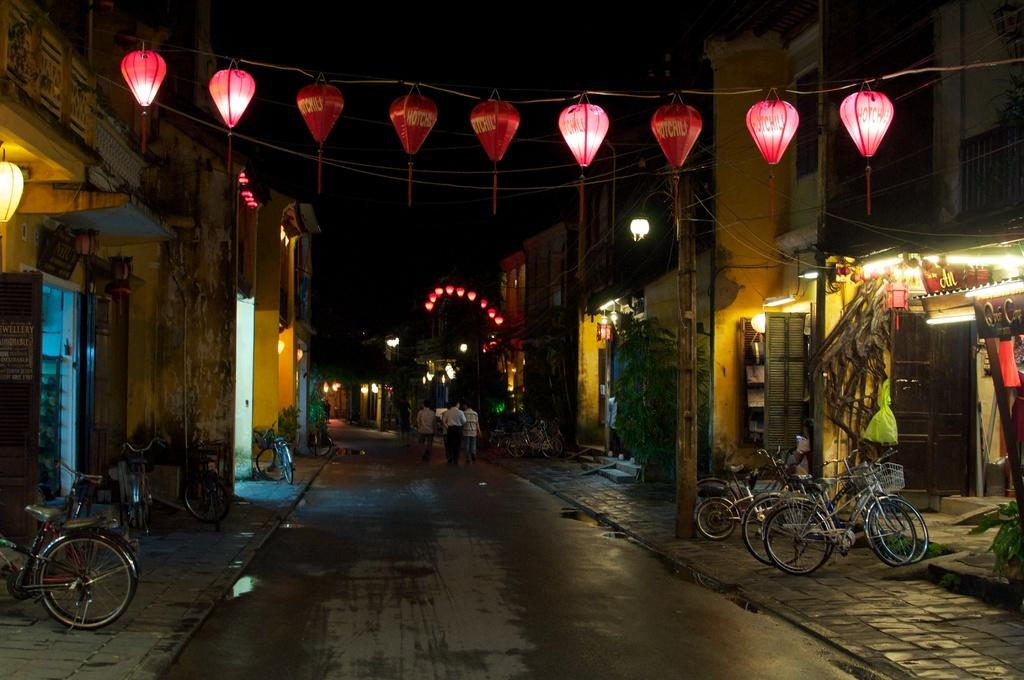What can be seen parked on the sidewalk in the image? There are bicycles parked on the sidewalk in the image. What are the people in the image doing? People are walking on the road in the image. What type of lighting is present in the area? Lamps are hanged in the area, providing lighting. What can be seen on either side of the road? There are buildings on either side of the road. How would you describe the background of the image? The background appears to be dark in color. Can you tell me how many notebooks are being used by the people walking on the road? There is no mention of notebooks in the image; people are walking on the road without any visible notebooks. Are the people in the image playing any games or sports? There is no indication of any games or sports being played in the image; people are simply walking on the road. 